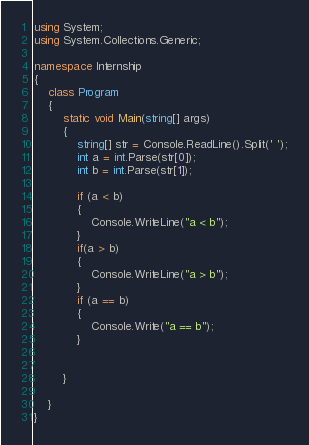<code> <loc_0><loc_0><loc_500><loc_500><_C#_>using System;
using System.Collections.Generic;

namespace Internship
{
    class Program
    {
        static void Main(string[] args)
        {
            string[] str = Console.ReadLine().Split(' ');
            int a = int.Parse(str[0]);
            int b = int.Parse(str[1]);
            
            if (a < b)
            {
                Console.WriteLine("a < b"); 
            }
            if(a > b)
            {
                Console.WriteLine("a > b");
            }
            if (a == b)
            {
                Console.Write("a == b");
            }


        }

    }
}</code> 